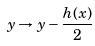<formula> <loc_0><loc_0><loc_500><loc_500>y \rightarrow y - \frac { h ( x ) } { 2 }</formula> 